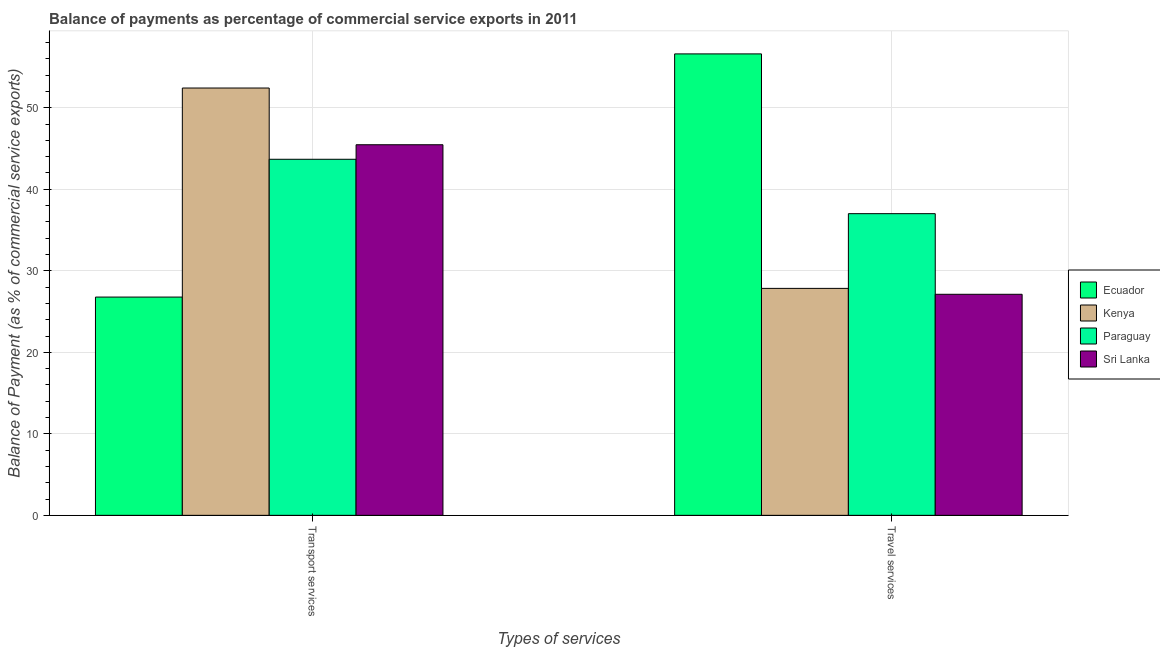How many different coloured bars are there?
Offer a terse response. 4. How many groups of bars are there?
Your answer should be compact. 2. Are the number of bars per tick equal to the number of legend labels?
Give a very brief answer. Yes. Are the number of bars on each tick of the X-axis equal?
Your answer should be very brief. Yes. What is the label of the 2nd group of bars from the left?
Provide a succinct answer. Travel services. What is the balance of payments of transport services in Ecuador?
Offer a very short reply. 26.78. Across all countries, what is the maximum balance of payments of travel services?
Offer a terse response. 56.61. Across all countries, what is the minimum balance of payments of travel services?
Ensure brevity in your answer.  27.12. In which country was the balance of payments of transport services maximum?
Offer a terse response. Kenya. In which country was the balance of payments of transport services minimum?
Keep it short and to the point. Ecuador. What is the total balance of payments of travel services in the graph?
Ensure brevity in your answer.  148.58. What is the difference between the balance of payments of transport services in Sri Lanka and that in Kenya?
Your answer should be very brief. -6.96. What is the difference between the balance of payments of travel services in Ecuador and the balance of payments of transport services in Kenya?
Your answer should be very brief. 4.19. What is the average balance of payments of travel services per country?
Offer a very short reply. 37.14. What is the difference between the balance of payments of travel services and balance of payments of transport services in Ecuador?
Your response must be concise. 29.83. What is the ratio of the balance of payments of travel services in Paraguay to that in Ecuador?
Keep it short and to the point. 0.65. In how many countries, is the balance of payments of transport services greater than the average balance of payments of transport services taken over all countries?
Your answer should be very brief. 3. What does the 3rd bar from the left in Transport services represents?
Your answer should be compact. Paraguay. What does the 3rd bar from the right in Travel services represents?
Keep it short and to the point. Kenya. How many bars are there?
Your answer should be very brief. 8. Are all the bars in the graph horizontal?
Offer a terse response. No. How many countries are there in the graph?
Your answer should be compact. 4. What is the difference between two consecutive major ticks on the Y-axis?
Offer a very short reply. 10. Does the graph contain any zero values?
Your response must be concise. No. Where does the legend appear in the graph?
Provide a succinct answer. Center right. How many legend labels are there?
Offer a terse response. 4. How are the legend labels stacked?
Keep it short and to the point. Vertical. What is the title of the graph?
Give a very brief answer. Balance of payments as percentage of commercial service exports in 2011. Does "Djibouti" appear as one of the legend labels in the graph?
Ensure brevity in your answer.  No. What is the label or title of the X-axis?
Ensure brevity in your answer.  Types of services. What is the label or title of the Y-axis?
Your answer should be very brief. Balance of Payment (as % of commercial service exports). What is the Balance of Payment (as % of commercial service exports) of Ecuador in Transport services?
Your answer should be very brief. 26.78. What is the Balance of Payment (as % of commercial service exports) of Kenya in Transport services?
Your answer should be very brief. 52.42. What is the Balance of Payment (as % of commercial service exports) in Paraguay in Transport services?
Ensure brevity in your answer.  43.68. What is the Balance of Payment (as % of commercial service exports) in Sri Lanka in Transport services?
Your answer should be compact. 45.46. What is the Balance of Payment (as % of commercial service exports) in Ecuador in Travel services?
Make the answer very short. 56.61. What is the Balance of Payment (as % of commercial service exports) of Kenya in Travel services?
Make the answer very short. 27.84. What is the Balance of Payment (as % of commercial service exports) of Paraguay in Travel services?
Provide a short and direct response. 37.01. What is the Balance of Payment (as % of commercial service exports) in Sri Lanka in Travel services?
Provide a short and direct response. 27.12. Across all Types of services, what is the maximum Balance of Payment (as % of commercial service exports) in Ecuador?
Your response must be concise. 56.61. Across all Types of services, what is the maximum Balance of Payment (as % of commercial service exports) of Kenya?
Give a very brief answer. 52.42. Across all Types of services, what is the maximum Balance of Payment (as % of commercial service exports) of Paraguay?
Your answer should be compact. 43.68. Across all Types of services, what is the maximum Balance of Payment (as % of commercial service exports) of Sri Lanka?
Your answer should be very brief. 45.46. Across all Types of services, what is the minimum Balance of Payment (as % of commercial service exports) of Ecuador?
Provide a succinct answer. 26.78. Across all Types of services, what is the minimum Balance of Payment (as % of commercial service exports) in Kenya?
Your response must be concise. 27.84. Across all Types of services, what is the minimum Balance of Payment (as % of commercial service exports) in Paraguay?
Offer a very short reply. 37.01. Across all Types of services, what is the minimum Balance of Payment (as % of commercial service exports) of Sri Lanka?
Provide a succinct answer. 27.12. What is the total Balance of Payment (as % of commercial service exports) in Ecuador in the graph?
Your response must be concise. 83.38. What is the total Balance of Payment (as % of commercial service exports) of Kenya in the graph?
Make the answer very short. 80.26. What is the total Balance of Payment (as % of commercial service exports) of Paraguay in the graph?
Your response must be concise. 80.69. What is the total Balance of Payment (as % of commercial service exports) in Sri Lanka in the graph?
Offer a terse response. 72.58. What is the difference between the Balance of Payment (as % of commercial service exports) in Ecuador in Transport services and that in Travel services?
Offer a very short reply. -29.83. What is the difference between the Balance of Payment (as % of commercial service exports) of Kenya in Transport services and that in Travel services?
Offer a very short reply. 24.58. What is the difference between the Balance of Payment (as % of commercial service exports) in Paraguay in Transport services and that in Travel services?
Ensure brevity in your answer.  6.67. What is the difference between the Balance of Payment (as % of commercial service exports) in Sri Lanka in Transport services and that in Travel services?
Your answer should be compact. 18.35. What is the difference between the Balance of Payment (as % of commercial service exports) in Ecuador in Transport services and the Balance of Payment (as % of commercial service exports) in Kenya in Travel services?
Your answer should be very brief. -1.07. What is the difference between the Balance of Payment (as % of commercial service exports) of Ecuador in Transport services and the Balance of Payment (as % of commercial service exports) of Paraguay in Travel services?
Keep it short and to the point. -10.23. What is the difference between the Balance of Payment (as % of commercial service exports) of Ecuador in Transport services and the Balance of Payment (as % of commercial service exports) of Sri Lanka in Travel services?
Offer a very short reply. -0.34. What is the difference between the Balance of Payment (as % of commercial service exports) of Kenya in Transport services and the Balance of Payment (as % of commercial service exports) of Paraguay in Travel services?
Offer a terse response. 15.41. What is the difference between the Balance of Payment (as % of commercial service exports) in Kenya in Transport services and the Balance of Payment (as % of commercial service exports) in Sri Lanka in Travel services?
Make the answer very short. 25.3. What is the difference between the Balance of Payment (as % of commercial service exports) in Paraguay in Transport services and the Balance of Payment (as % of commercial service exports) in Sri Lanka in Travel services?
Your response must be concise. 16.56. What is the average Balance of Payment (as % of commercial service exports) of Ecuador per Types of services?
Your answer should be compact. 41.69. What is the average Balance of Payment (as % of commercial service exports) of Kenya per Types of services?
Ensure brevity in your answer.  40.13. What is the average Balance of Payment (as % of commercial service exports) in Paraguay per Types of services?
Offer a very short reply. 40.34. What is the average Balance of Payment (as % of commercial service exports) of Sri Lanka per Types of services?
Make the answer very short. 36.29. What is the difference between the Balance of Payment (as % of commercial service exports) of Ecuador and Balance of Payment (as % of commercial service exports) of Kenya in Transport services?
Give a very brief answer. -25.65. What is the difference between the Balance of Payment (as % of commercial service exports) of Ecuador and Balance of Payment (as % of commercial service exports) of Paraguay in Transport services?
Your answer should be very brief. -16.9. What is the difference between the Balance of Payment (as % of commercial service exports) of Ecuador and Balance of Payment (as % of commercial service exports) of Sri Lanka in Transport services?
Your answer should be very brief. -18.69. What is the difference between the Balance of Payment (as % of commercial service exports) of Kenya and Balance of Payment (as % of commercial service exports) of Paraguay in Transport services?
Your response must be concise. 8.74. What is the difference between the Balance of Payment (as % of commercial service exports) of Kenya and Balance of Payment (as % of commercial service exports) of Sri Lanka in Transport services?
Provide a short and direct response. 6.96. What is the difference between the Balance of Payment (as % of commercial service exports) of Paraguay and Balance of Payment (as % of commercial service exports) of Sri Lanka in Transport services?
Your answer should be very brief. -1.78. What is the difference between the Balance of Payment (as % of commercial service exports) in Ecuador and Balance of Payment (as % of commercial service exports) in Kenya in Travel services?
Ensure brevity in your answer.  28.76. What is the difference between the Balance of Payment (as % of commercial service exports) in Ecuador and Balance of Payment (as % of commercial service exports) in Paraguay in Travel services?
Provide a short and direct response. 19.6. What is the difference between the Balance of Payment (as % of commercial service exports) in Ecuador and Balance of Payment (as % of commercial service exports) in Sri Lanka in Travel services?
Give a very brief answer. 29.49. What is the difference between the Balance of Payment (as % of commercial service exports) of Kenya and Balance of Payment (as % of commercial service exports) of Paraguay in Travel services?
Offer a very short reply. -9.17. What is the difference between the Balance of Payment (as % of commercial service exports) of Kenya and Balance of Payment (as % of commercial service exports) of Sri Lanka in Travel services?
Ensure brevity in your answer.  0.73. What is the difference between the Balance of Payment (as % of commercial service exports) of Paraguay and Balance of Payment (as % of commercial service exports) of Sri Lanka in Travel services?
Ensure brevity in your answer.  9.89. What is the ratio of the Balance of Payment (as % of commercial service exports) in Ecuador in Transport services to that in Travel services?
Keep it short and to the point. 0.47. What is the ratio of the Balance of Payment (as % of commercial service exports) of Kenya in Transport services to that in Travel services?
Ensure brevity in your answer.  1.88. What is the ratio of the Balance of Payment (as % of commercial service exports) in Paraguay in Transport services to that in Travel services?
Provide a succinct answer. 1.18. What is the ratio of the Balance of Payment (as % of commercial service exports) in Sri Lanka in Transport services to that in Travel services?
Provide a succinct answer. 1.68. What is the difference between the highest and the second highest Balance of Payment (as % of commercial service exports) in Ecuador?
Offer a very short reply. 29.83. What is the difference between the highest and the second highest Balance of Payment (as % of commercial service exports) of Kenya?
Your answer should be compact. 24.58. What is the difference between the highest and the second highest Balance of Payment (as % of commercial service exports) in Paraguay?
Give a very brief answer. 6.67. What is the difference between the highest and the second highest Balance of Payment (as % of commercial service exports) in Sri Lanka?
Ensure brevity in your answer.  18.35. What is the difference between the highest and the lowest Balance of Payment (as % of commercial service exports) in Ecuador?
Your answer should be very brief. 29.83. What is the difference between the highest and the lowest Balance of Payment (as % of commercial service exports) in Kenya?
Your answer should be compact. 24.58. What is the difference between the highest and the lowest Balance of Payment (as % of commercial service exports) of Paraguay?
Your answer should be compact. 6.67. What is the difference between the highest and the lowest Balance of Payment (as % of commercial service exports) of Sri Lanka?
Provide a succinct answer. 18.35. 